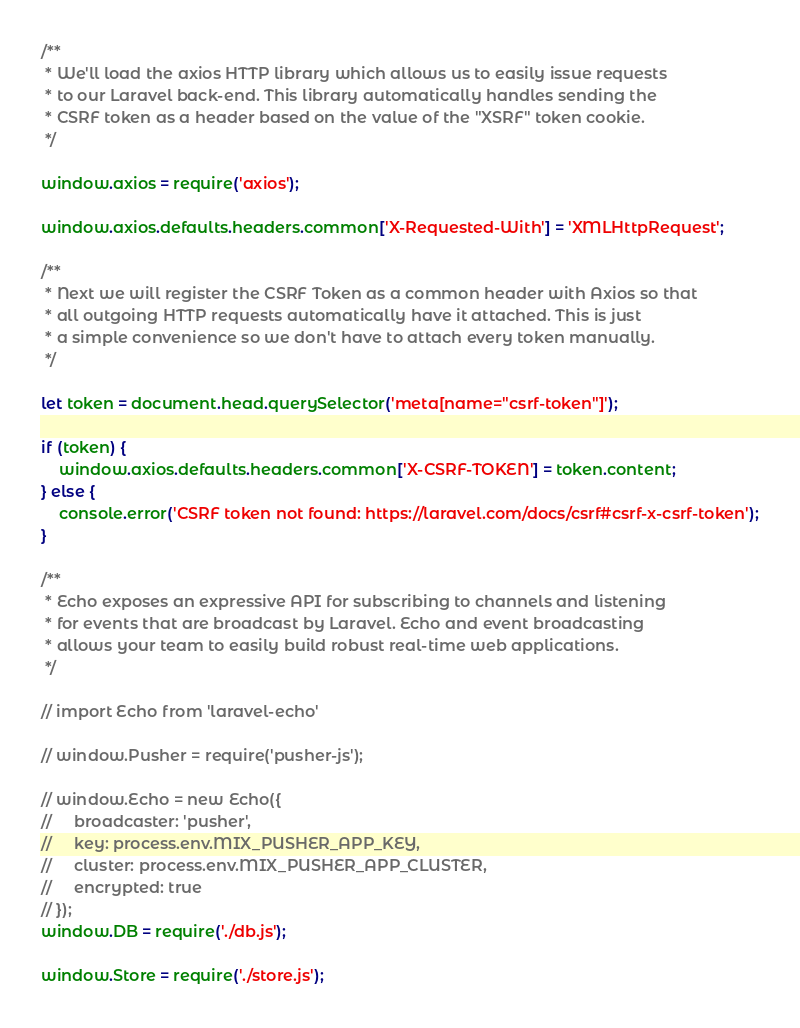<code> <loc_0><loc_0><loc_500><loc_500><_JavaScript_>
/**
 * We'll load the axios HTTP library which allows us to easily issue requests
 * to our Laravel back-end. This library automatically handles sending the
 * CSRF token as a header based on the value of the "XSRF" token cookie.
 */

window.axios = require('axios');

window.axios.defaults.headers.common['X-Requested-With'] = 'XMLHttpRequest';

/**
 * Next we will register the CSRF Token as a common header with Axios so that
 * all outgoing HTTP requests automatically have it attached. This is just
 * a simple convenience so we don't have to attach every token manually.
 */

let token = document.head.querySelector('meta[name="csrf-token"]');

if (token) {
    window.axios.defaults.headers.common['X-CSRF-TOKEN'] = token.content;
} else {
    console.error('CSRF token not found: https://laravel.com/docs/csrf#csrf-x-csrf-token');
}

/**
 * Echo exposes an expressive API for subscribing to channels and listening
 * for events that are broadcast by Laravel. Echo and event broadcasting
 * allows your team to easily build robust real-time web applications.
 */

// import Echo from 'laravel-echo'

// window.Pusher = require('pusher-js');

// window.Echo = new Echo({
//     broadcaster: 'pusher',
//     key: process.env.MIX_PUSHER_APP_KEY,
//     cluster: process.env.MIX_PUSHER_APP_CLUSTER,
//     encrypted: true
// });
window.DB = require('./db.js');

window.Store = require('./store.js');</code> 